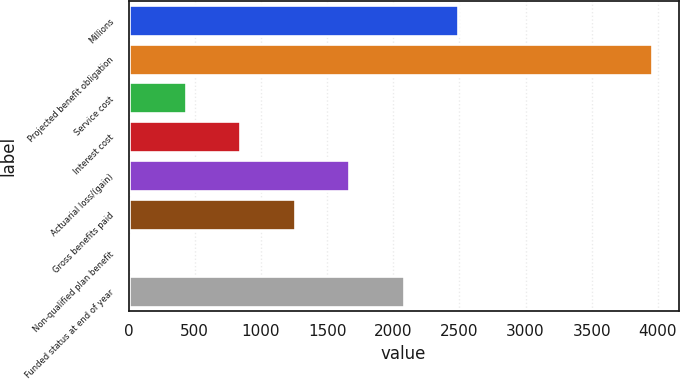<chart> <loc_0><loc_0><loc_500><loc_500><bar_chart><fcel>Millions<fcel>Projected benefit obligation<fcel>Service cost<fcel>Interest cost<fcel>Actuarial loss/(gain)<fcel>Gross benefits paid<fcel>Non-qualified plan benefit<fcel>Funded status at end of year<nl><fcel>2492.8<fcel>3958<fcel>431.3<fcel>843.6<fcel>1668.2<fcel>1255.9<fcel>19<fcel>2080.5<nl></chart> 